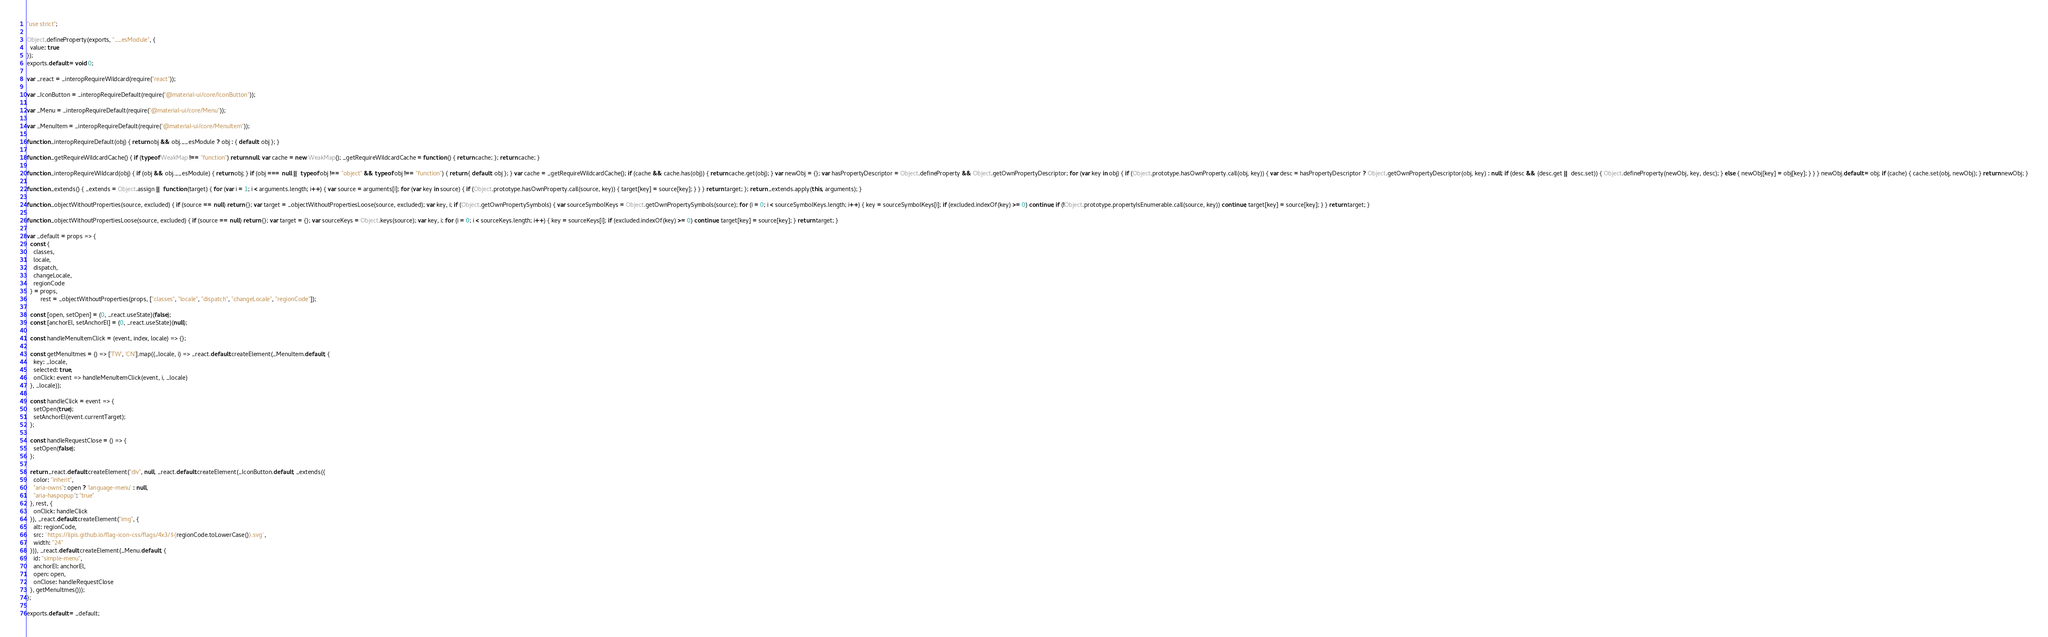Convert code to text. <code><loc_0><loc_0><loc_500><loc_500><_JavaScript_>"use strict";

Object.defineProperty(exports, "__esModule", {
  value: true
});
exports.default = void 0;

var _react = _interopRequireWildcard(require("react"));

var _IconButton = _interopRequireDefault(require("@material-ui/core/IconButton"));

var _Menu = _interopRequireDefault(require("@material-ui/core/Menu"));

var _MenuItem = _interopRequireDefault(require("@material-ui/core/MenuItem"));

function _interopRequireDefault(obj) { return obj && obj.__esModule ? obj : { default: obj }; }

function _getRequireWildcardCache() { if (typeof WeakMap !== "function") return null; var cache = new WeakMap(); _getRequireWildcardCache = function () { return cache; }; return cache; }

function _interopRequireWildcard(obj) { if (obj && obj.__esModule) { return obj; } if (obj === null || typeof obj !== "object" && typeof obj !== "function") { return { default: obj }; } var cache = _getRequireWildcardCache(); if (cache && cache.has(obj)) { return cache.get(obj); } var newObj = {}; var hasPropertyDescriptor = Object.defineProperty && Object.getOwnPropertyDescriptor; for (var key in obj) { if (Object.prototype.hasOwnProperty.call(obj, key)) { var desc = hasPropertyDescriptor ? Object.getOwnPropertyDescriptor(obj, key) : null; if (desc && (desc.get || desc.set)) { Object.defineProperty(newObj, key, desc); } else { newObj[key] = obj[key]; } } } newObj.default = obj; if (cache) { cache.set(obj, newObj); } return newObj; }

function _extends() { _extends = Object.assign || function (target) { for (var i = 1; i < arguments.length; i++) { var source = arguments[i]; for (var key in source) { if (Object.prototype.hasOwnProperty.call(source, key)) { target[key] = source[key]; } } } return target; }; return _extends.apply(this, arguments); }

function _objectWithoutProperties(source, excluded) { if (source == null) return {}; var target = _objectWithoutPropertiesLoose(source, excluded); var key, i; if (Object.getOwnPropertySymbols) { var sourceSymbolKeys = Object.getOwnPropertySymbols(source); for (i = 0; i < sourceSymbolKeys.length; i++) { key = sourceSymbolKeys[i]; if (excluded.indexOf(key) >= 0) continue; if (!Object.prototype.propertyIsEnumerable.call(source, key)) continue; target[key] = source[key]; } } return target; }

function _objectWithoutPropertiesLoose(source, excluded) { if (source == null) return {}; var target = {}; var sourceKeys = Object.keys(source); var key, i; for (i = 0; i < sourceKeys.length; i++) { key = sourceKeys[i]; if (excluded.indexOf(key) >= 0) continue; target[key] = source[key]; } return target; }

var _default = props => {
  const {
    classes,
    locale,
    dispatch,
    changeLocale,
    regionCode
  } = props,
        rest = _objectWithoutProperties(props, ["classes", "locale", "dispatch", "changeLocale", "regionCode"]);

  const [open, setOpen] = (0, _react.useState)(false);
  const [anchorEl, setAnchorEl] = (0, _react.useState)(null);

  const handleMenuItemClick = (event, index, locale) => {};

  const getMenuItmes = () => ['TW', 'CN'].map((_locale, i) => _react.default.createElement(_MenuItem.default, {
    key: _locale,
    selected: true,
    onClick: event => handleMenuItemClick(event, i, _locale)
  }, _locale));

  const handleClick = event => {
    setOpen(true);
    setAnchorEl(event.currentTarget);
  };

  const handleRequestClose = () => {
    setOpen(false);
  };

  return _react.default.createElement("div", null, _react.default.createElement(_IconButton.default, _extends({
    color: "inherit",
    "aria-owns": open ? 'language-menu' : null,
    "aria-haspopup": "true"
  }, rest, {
    onClick: handleClick
  }), _react.default.createElement("img", {
    alt: regionCode,
    src: `https://lipis.github.io/flag-icon-css/flags/4x3/${regionCode.toLowerCase()}.svg`,
    width: "24"
  })), _react.default.createElement(_Menu.default, {
    id: "simple-menu",
    anchorEl: anchorEl,
    open: open,
    onClose: handleRequestClose
  }, getMenuItmes()));
};

exports.default = _default;</code> 